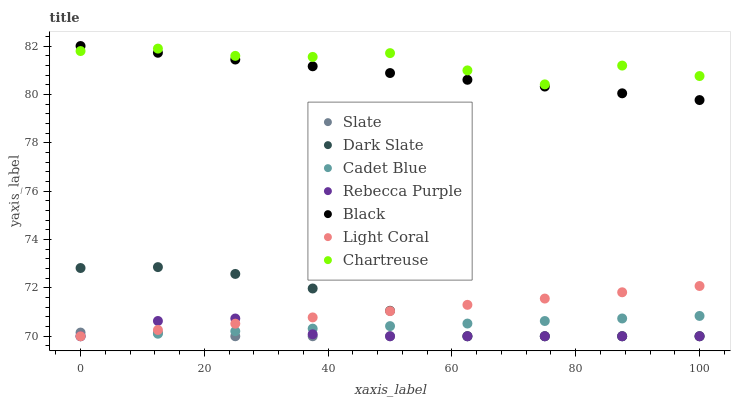Does Slate have the minimum area under the curve?
Answer yes or no. Yes. Does Chartreuse have the maximum area under the curve?
Answer yes or no. Yes. Does Light Coral have the minimum area under the curve?
Answer yes or no. No. Does Light Coral have the maximum area under the curve?
Answer yes or no. No. Is Black the smoothest?
Answer yes or no. Yes. Is Chartreuse the roughest?
Answer yes or no. Yes. Is Slate the smoothest?
Answer yes or no. No. Is Slate the roughest?
Answer yes or no. No. Does Cadet Blue have the lowest value?
Answer yes or no. Yes. Does Chartreuse have the lowest value?
Answer yes or no. No. Does Black have the highest value?
Answer yes or no. Yes. Does Light Coral have the highest value?
Answer yes or no. No. Is Rebecca Purple less than Black?
Answer yes or no. Yes. Is Chartreuse greater than Cadet Blue?
Answer yes or no. Yes. Does Rebecca Purple intersect Slate?
Answer yes or no. Yes. Is Rebecca Purple less than Slate?
Answer yes or no. No. Is Rebecca Purple greater than Slate?
Answer yes or no. No. Does Rebecca Purple intersect Black?
Answer yes or no. No. 